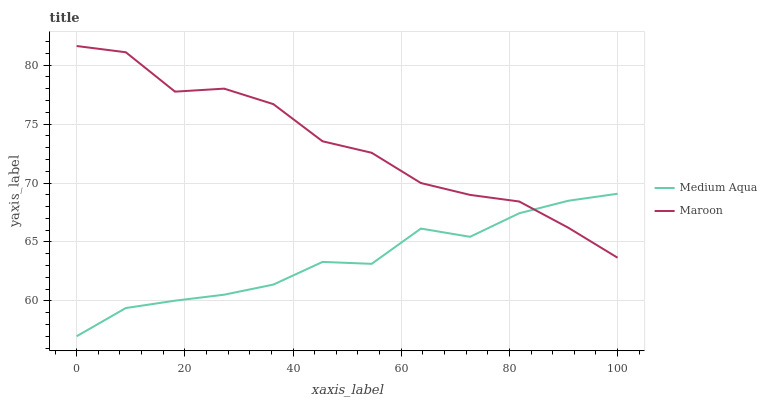Does Medium Aqua have the minimum area under the curve?
Answer yes or no. Yes. Does Maroon have the maximum area under the curve?
Answer yes or no. Yes. Does Maroon have the minimum area under the curve?
Answer yes or no. No. Is Medium Aqua the smoothest?
Answer yes or no. Yes. Is Maroon the roughest?
Answer yes or no. Yes. Is Maroon the smoothest?
Answer yes or no. No. Does Medium Aqua have the lowest value?
Answer yes or no. Yes. Does Maroon have the lowest value?
Answer yes or no. No. Does Maroon have the highest value?
Answer yes or no. Yes. Does Medium Aqua intersect Maroon?
Answer yes or no. Yes. Is Medium Aqua less than Maroon?
Answer yes or no. No. Is Medium Aqua greater than Maroon?
Answer yes or no. No. 